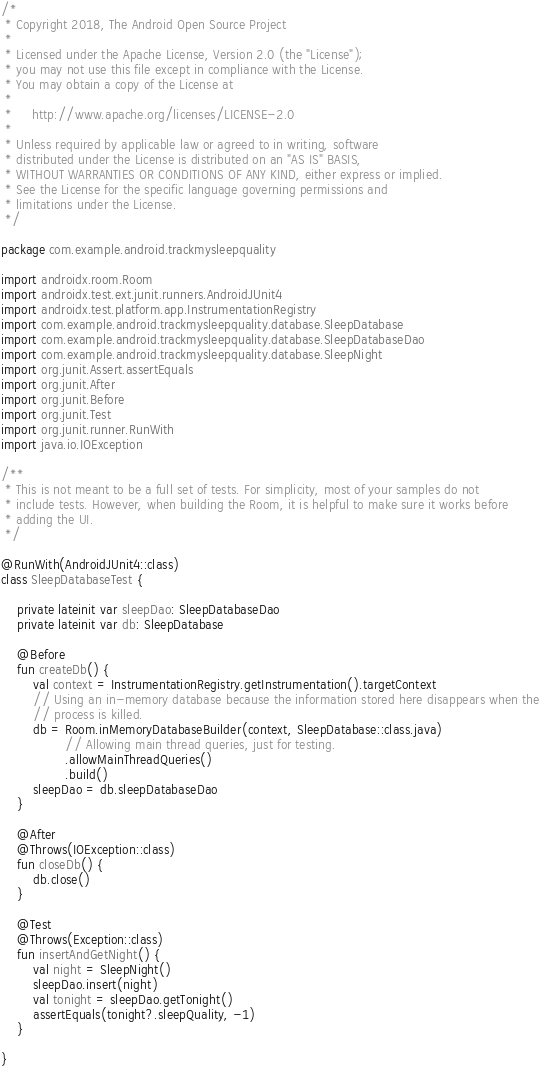Convert code to text. <code><loc_0><loc_0><loc_500><loc_500><_Kotlin_>/*
 * Copyright 2018, The Android Open Source Project
 *
 * Licensed under the Apache License, Version 2.0 (the "License");
 * you may not use this file except in compliance with the License.
 * You may obtain a copy of the License at
 *
 *     http://www.apache.org/licenses/LICENSE-2.0
 *
 * Unless required by applicable law or agreed to in writing, software
 * distributed under the License is distributed on an "AS IS" BASIS,
 * WITHOUT WARRANTIES OR CONDITIONS OF ANY KIND, either express or implied.
 * See the License for the specific language governing permissions and
 * limitations under the License.
 */

package com.example.android.trackmysleepquality

import androidx.room.Room
import androidx.test.ext.junit.runners.AndroidJUnit4
import androidx.test.platform.app.InstrumentationRegistry
import com.example.android.trackmysleepquality.database.SleepDatabase
import com.example.android.trackmysleepquality.database.SleepDatabaseDao
import com.example.android.trackmysleepquality.database.SleepNight
import org.junit.Assert.assertEquals
import org.junit.After
import org.junit.Before
import org.junit.Test
import org.junit.runner.RunWith
import java.io.IOException

/**
 * This is not meant to be a full set of tests. For simplicity, most of your samples do not
 * include tests. However, when building the Room, it is helpful to make sure it works before
 * adding the UI.
 */

@RunWith(AndroidJUnit4::class)
class SleepDatabaseTest {

    private lateinit var sleepDao: SleepDatabaseDao
    private lateinit var db: SleepDatabase

    @Before
    fun createDb() {
        val context = InstrumentationRegistry.getInstrumentation().targetContext
        // Using an in-memory database because the information stored here disappears when the
        // process is killed.
        db = Room.inMemoryDatabaseBuilder(context, SleepDatabase::class.java)
                // Allowing main thread queries, just for testing.
                .allowMainThreadQueries()
                .build()
        sleepDao = db.sleepDatabaseDao
    }

    @After
    @Throws(IOException::class)
    fun closeDb() {
        db.close()
    }

    @Test
    @Throws(Exception::class)
    fun insertAndGetNight() {
        val night = SleepNight()
        sleepDao.insert(night)
        val tonight = sleepDao.getTonight()
        assertEquals(tonight?.sleepQuality, -1)
    }

}
</code> 